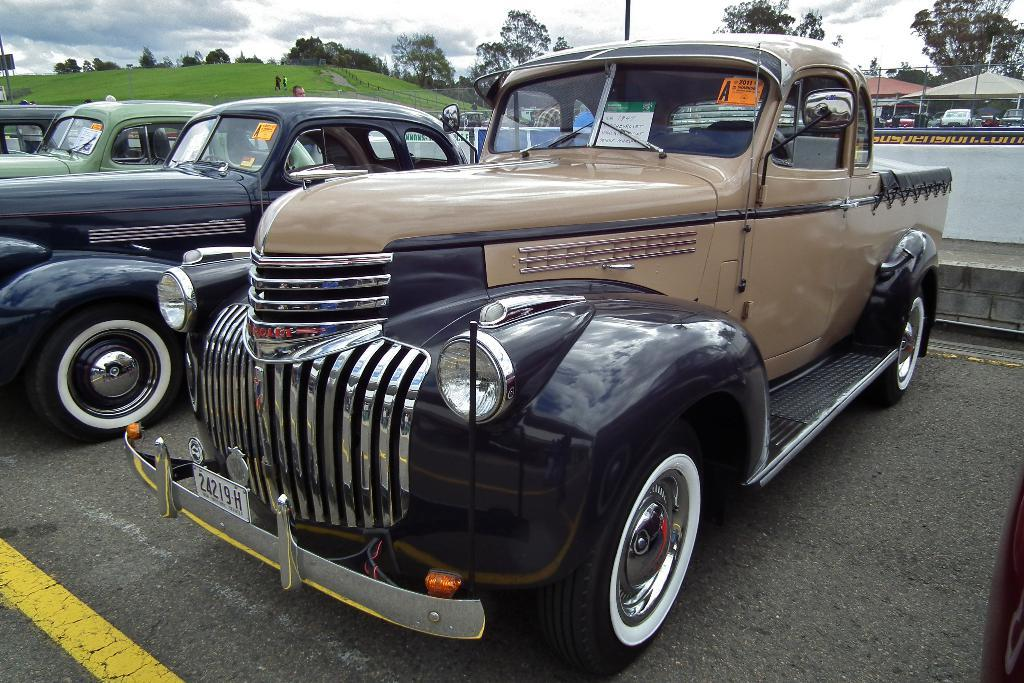What can be seen in the image in terms of transportation? There are many vehicles in the image. What type of natural elements can be seen in the background of the image? There are trees and a hill in the background of the image. What type of structures are present in the background of the image? There are small sheds in the background of the image. What is visible in the sky in the image? The sky is visible in the background of the image, and there are clouds in the sky. What type of gate can be seen in the image? There is no gate present in the image. What kind of pipe is visible in the image? There is no pipe visible in the image. 